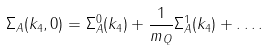Convert formula to latex. <formula><loc_0><loc_0><loc_500><loc_500>\Sigma _ { A } ( k _ { 4 } , 0 ) = \Sigma _ { A } ^ { 0 } ( k _ { 4 } ) + \frac { 1 } { m _ { Q } } \Sigma _ { A } ^ { 1 } ( k _ { 4 } ) + \dots .</formula> 